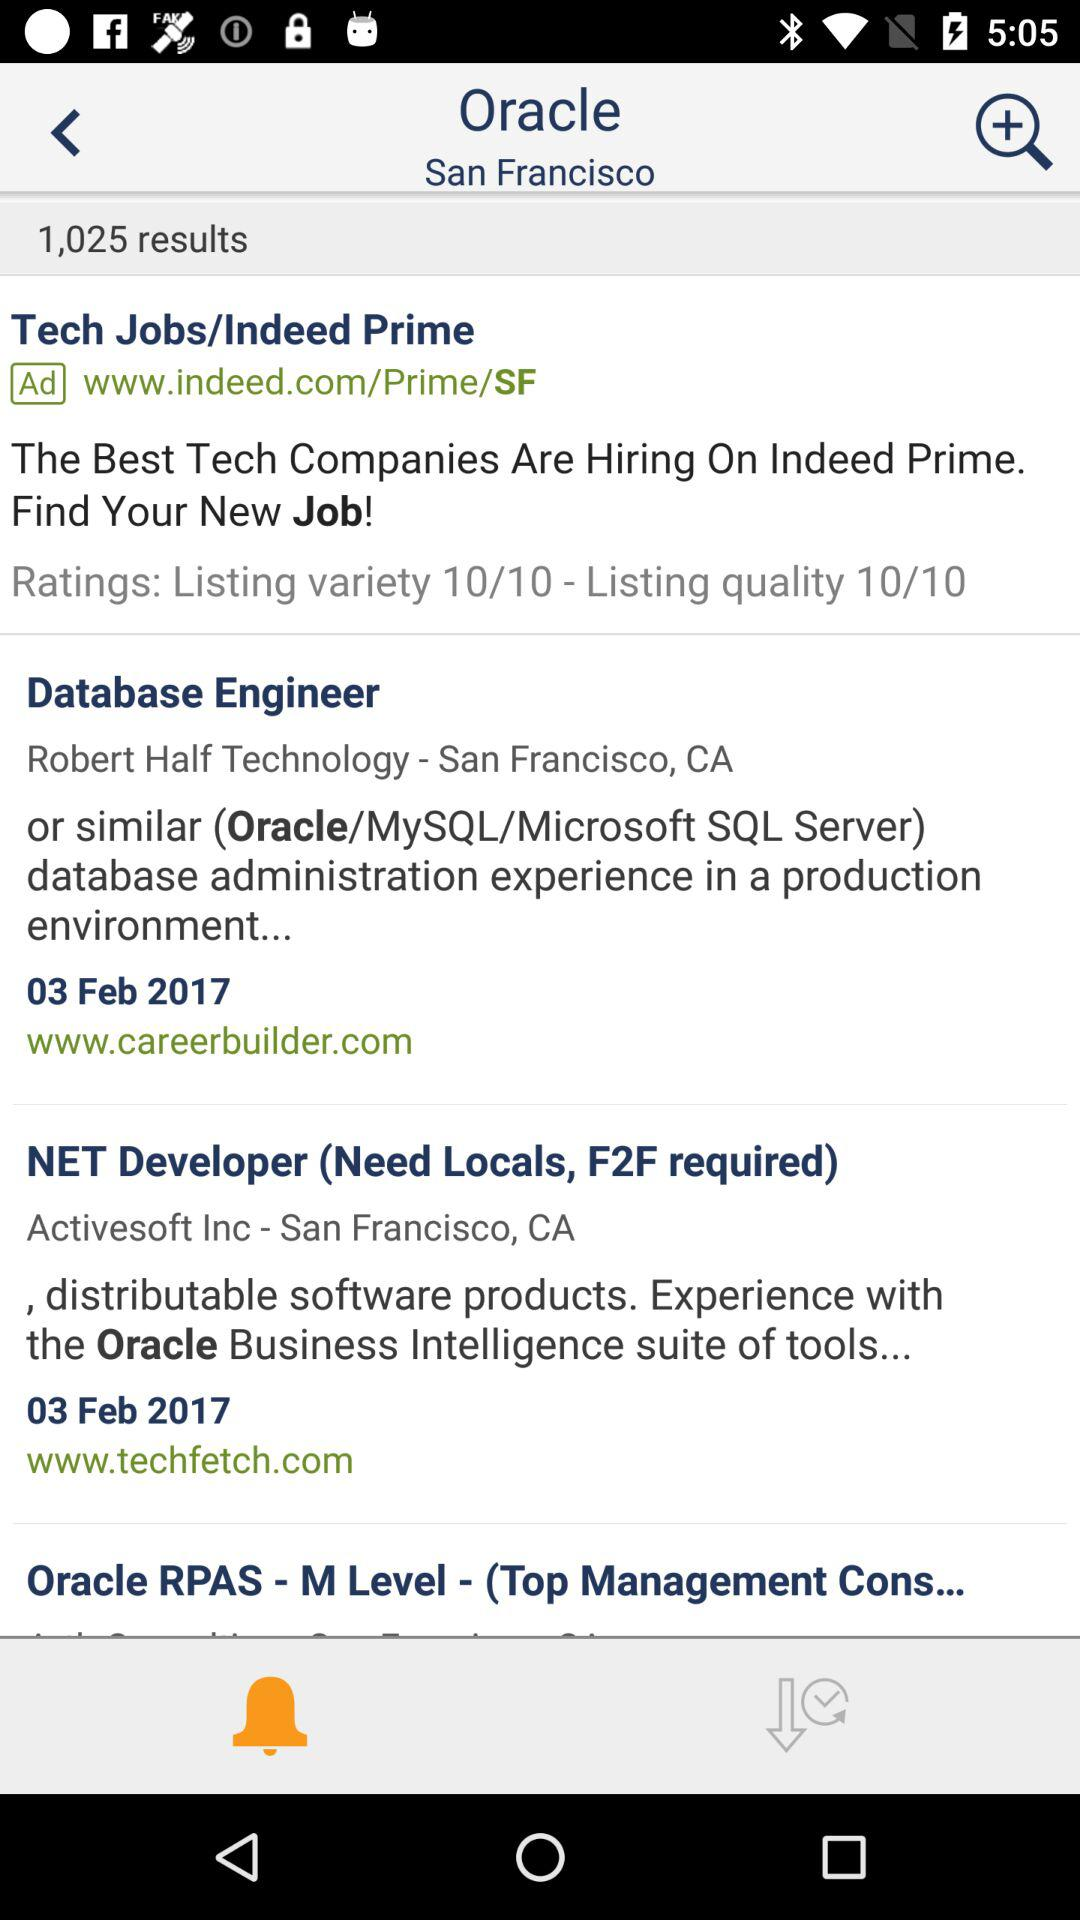How many of the results are ads?
Answer the question using a single word or phrase. 1 